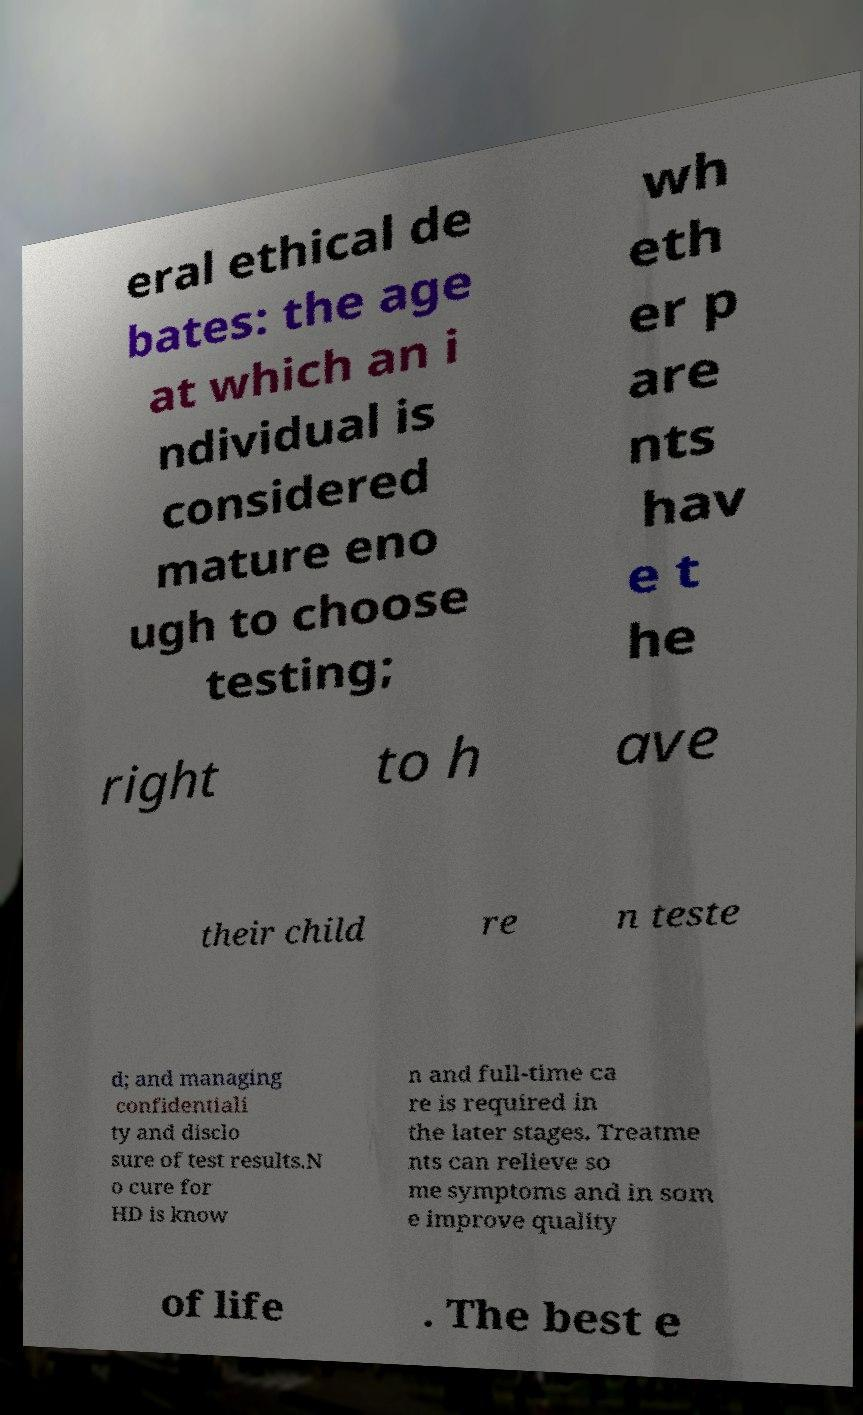What messages or text are displayed in this image? I need them in a readable, typed format. eral ethical de bates: the age at which an i ndividual is considered mature eno ugh to choose testing; wh eth er p are nts hav e t he right to h ave their child re n teste d; and managing confidentiali ty and disclo sure of test results.N o cure for HD is know n and full-time ca re is required in the later stages. Treatme nts can relieve so me symptoms and in som e improve quality of life . The best e 